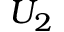Convert formula to latex. <formula><loc_0><loc_0><loc_500><loc_500>U _ { 2 }</formula> 